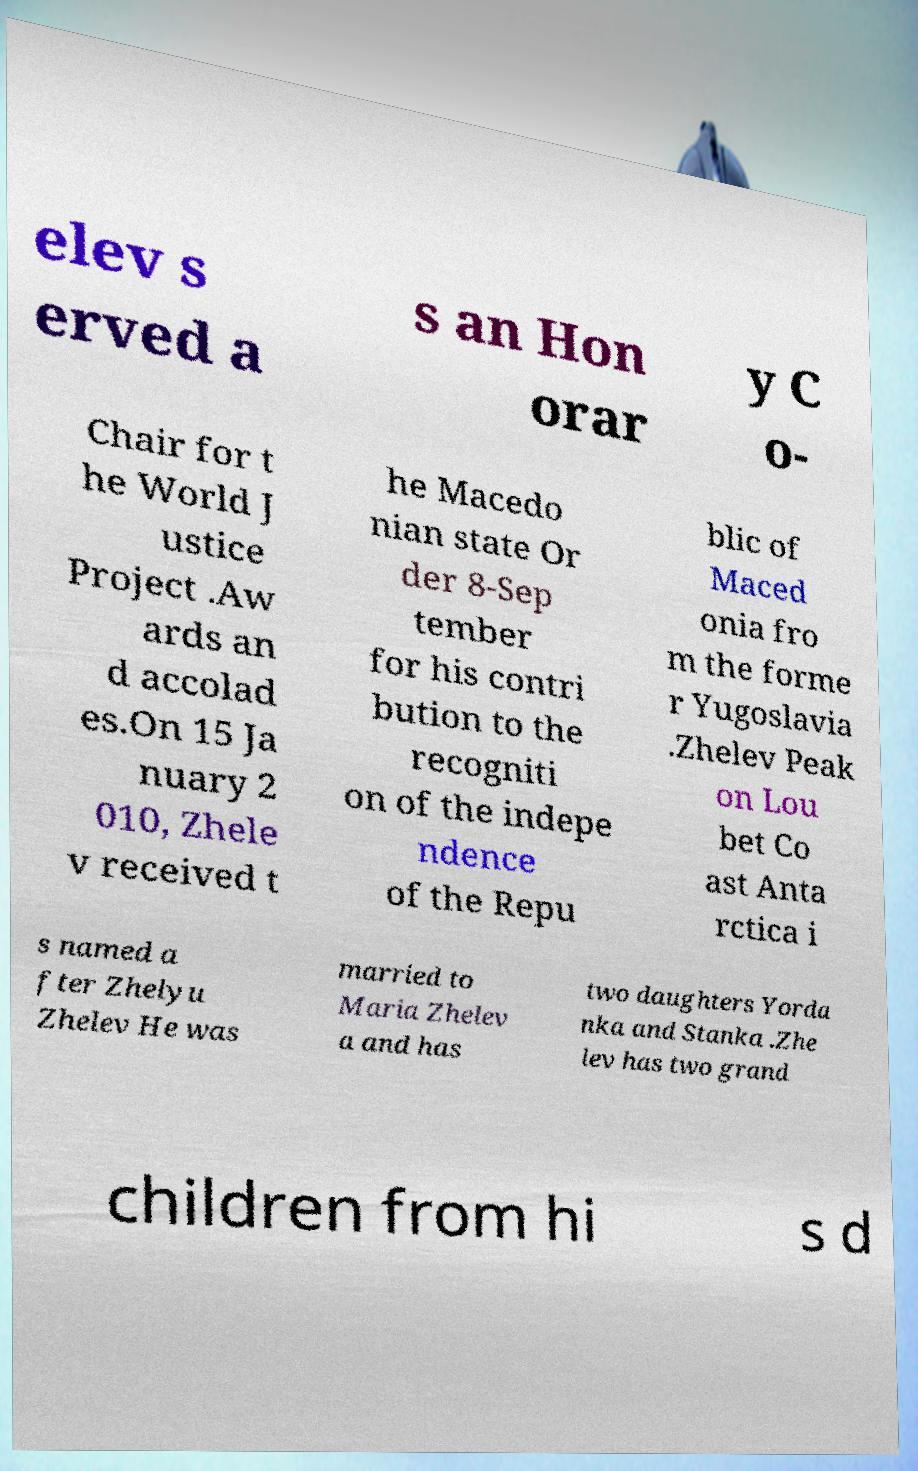There's text embedded in this image that I need extracted. Can you transcribe it verbatim? elev s erved a s an Hon orar y C o- Chair for t he World J ustice Project .Aw ards an d accolad es.On 15 Ja nuary 2 010, Zhele v received t he Macedo nian state Or der 8-Sep tember for his contri bution to the recogniti on of the indepe ndence of the Repu blic of Maced onia fro m the forme r Yugoslavia .Zhelev Peak on Lou bet Co ast Anta rctica i s named a fter Zhelyu Zhelev He was married to Maria Zhelev a and has two daughters Yorda nka and Stanka .Zhe lev has two grand children from hi s d 